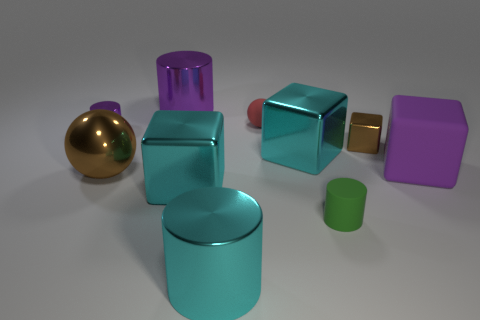Subtract all cyan cubes. Subtract all brown spheres. How many cubes are left? 2 Subtract all cylinders. How many objects are left? 6 Subtract all purple metallic cylinders. Subtract all cyan cubes. How many objects are left? 6 Add 8 tiny purple cylinders. How many tiny purple cylinders are left? 9 Add 3 small red rubber objects. How many small red rubber objects exist? 4 Subtract 0 green cubes. How many objects are left? 10 